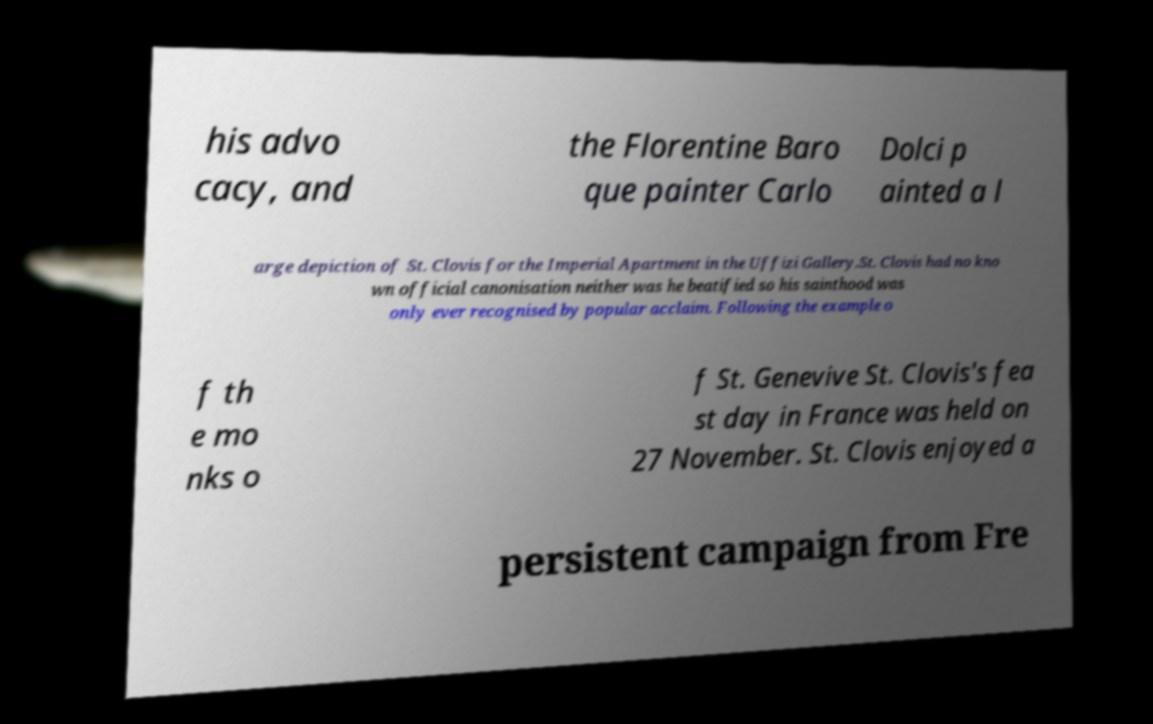Please read and relay the text visible in this image. What does it say? his advo cacy, and the Florentine Baro que painter Carlo Dolci p ainted a l arge depiction of St. Clovis for the Imperial Apartment in the Uffizi Gallery.St. Clovis had no kno wn official canonisation neither was he beatified so his sainthood was only ever recognised by popular acclaim. Following the example o f th e mo nks o f St. Genevive St. Clovis's fea st day in France was held on 27 November. St. Clovis enjoyed a persistent campaign from Fre 